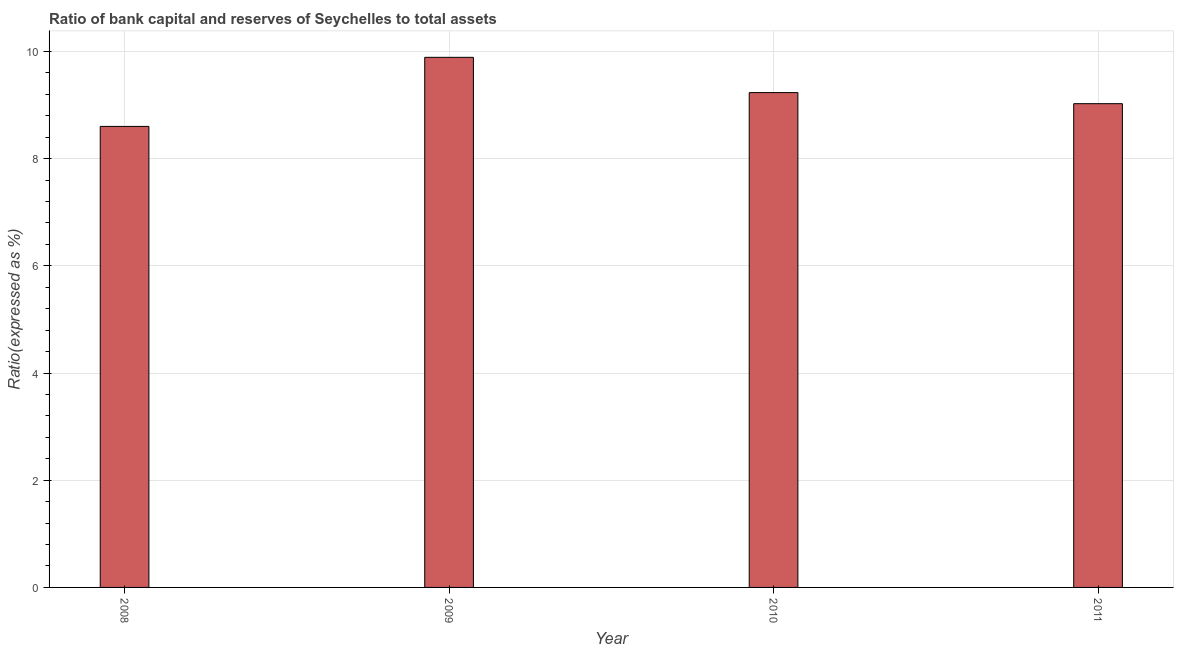What is the title of the graph?
Keep it short and to the point. Ratio of bank capital and reserves of Seychelles to total assets. What is the label or title of the Y-axis?
Your answer should be very brief. Ratio(expressed as %). What is the bank capital to assets ratio in 2010?
Ensure brevity in your answer.  9.23. Across all years, what is the maximum bank capital to assets ratio?
Keep it short and to the point. 9.89. Across all years, what is the minimum bank capital to assets ratio?
Provide a short and direct response. 8.6. What is the sum of the bank capital to assets ratio?
Keep it short and to the point. 36.75. What is the difference between the bank capital to assets ratio in 2008 and 2010?
Make the answer very short. -0.63. What is the average bank capital to assets ratio per year?
Offer a very short reply. 9.19. What is the median bank capital to assets ratio?
Give a very brief answer. 9.13. What is the ratio of the bank capital to assets ratio in 2008 to that in 2011?
Keep it short and to the point. 0.95. Is the bank capital to assets ratio in 2010 less than that in 2011?
Your response must be concise. No. What is the difference between the highest and the second highest bank capital to assets ratio?
Make the answer very short. 0.66. What is the difference between the highest and the lowest bank capital to assets ratio?
Offer a very short reply. 1.29. How many bars are there?
Your answer should be very brief. 4. Are the values on the major ticks of Y-axis written in scientific E-notation?
Offer a very short reply. No. What is the Ratio(expressed as %) in 2008?
Keep it short and to the point. 8.6. What is the Ratio(expressed as %) of 2009?
Offer a very short reply. 9.89. What is the Ratio(expressed as %) in 2010?
Offer a very short reply. 9.23. What is the Ratio(expressed as %) in 2011?
Your response must be concise. 9.03. What is the difference between the Ratio(expressed as %) in 2008 and 2009?
Your answer should be compact. -1.29. What is the difference between the Ratio(expressed as %) in 2008 and 2010?
Make the answer very short. -0.63. What is the difference between the Ratio(expressed as %) in 2008 and 2011?
Offer a very short reply. -0.42. What is the difference between the Ratio(expressed as %) in 2009 and 2010?
Your answer should be compact. 0.66. What is the difference between the Ratio(expressed as %) in 2009 and 2011?
Ensure brevity in your answer.  0.86. What is the difference between the Ratio(expressed as %) in 2010 and 2011?
Your answer should be very brief. 0.21. What is the ratio of the Ratio(expressed as %) in 2008 to that in 2009?
Make the answer very short. 0.87. What is the ratio of the Ratio(expressed as %) in 2008 to that in 2010?
Offer a terse response. 0.93. What is the ratio of the Ratio(expressed as %) in 2008 to that in 2011?
Provide a succinct answer. 0.95. What is the ratio of the Ratio(expressed as %) in 2009 to that in 2010?
Make the answer very short. 1.07. What is the ratio of the Ratio(expressed as %) in 2009 to that in 2011?
Provide a short and direct response. 1.1. 